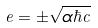Convert formula to latex. <formula><loc_0><loc_0><loc_500><loc_500>e = \pm \sqrt { \alpha \hbar { c } }</formula> 